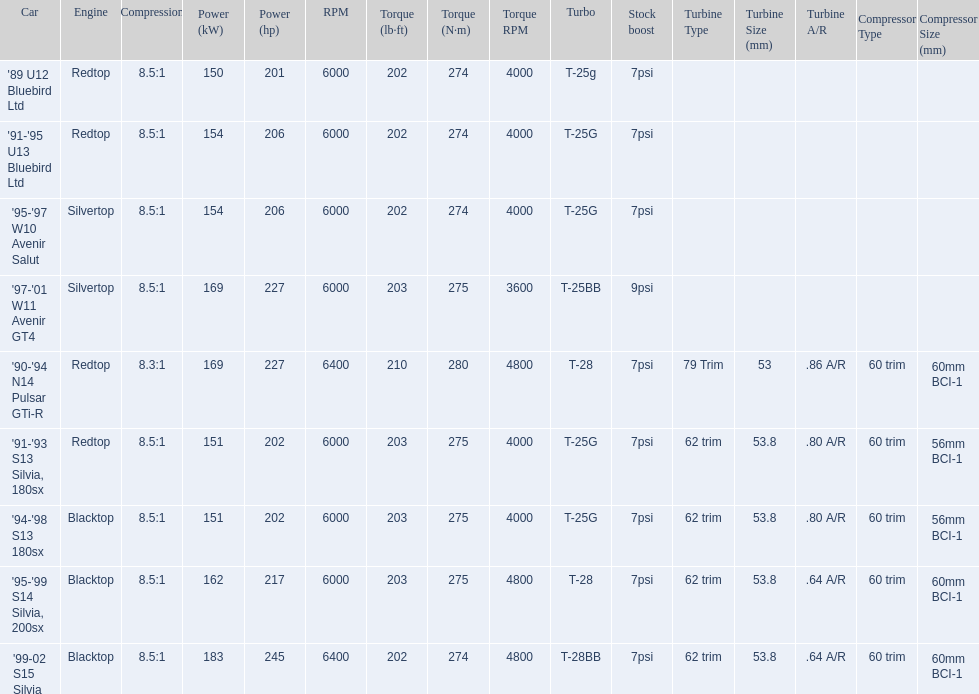What cars are there? '89 U12 Bluebird Ltd, 7psi, '91-'95 U13 Bluebird Ltd, 7psi, '95-'97 W10 Avenir Salut, 7psi, '97-'01 W11 Avenir GT4, 9psi, '90-'94 N14 Pulsar GTi-R, 7psi, '91-'93 S13 Silvia, 180sx, 7psi, '94-'98 S13 180sx, 7psi, '95-'99 S14 Silvia, 200sx, 7psi, '99-02 S15 Silvia, 7psi. Which stock boost is over 7psi? '97-'01 W11 Avenir GT4, 9psi. What car is it? '97-'01 W11 Avenir GT4. 